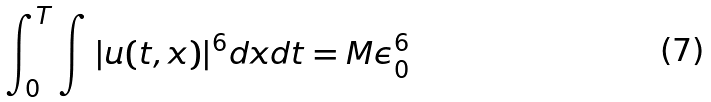<formula> <loc_0><loc_0><loc_500><loc_500>\int _ { 0 } ^ { T } \int | u ( t , x ) | ^ { 6 } d x d t = M \epsilon _ { 0 } ^ { 6 }</formula> 